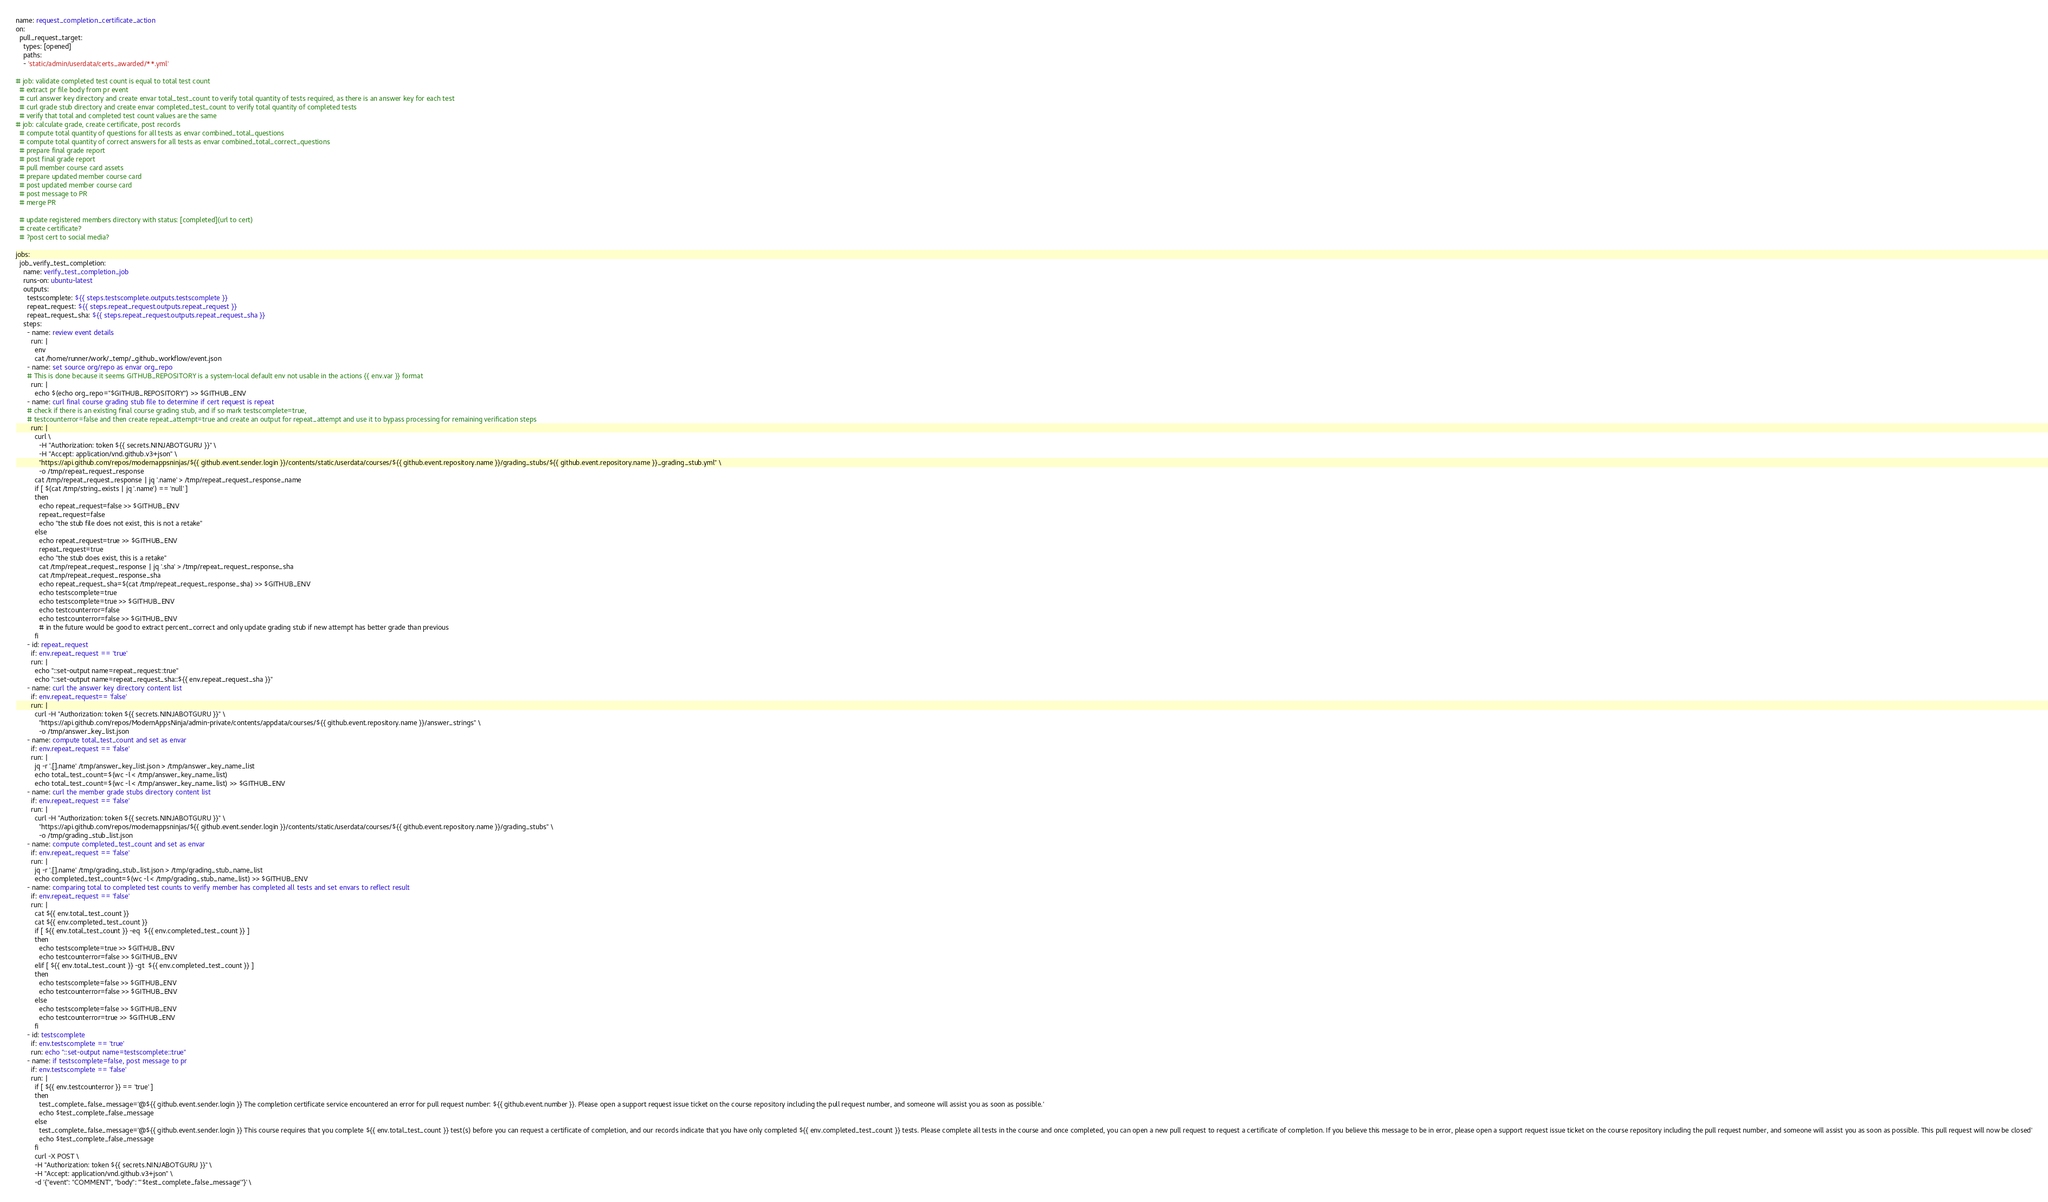<code> <loc_0><loc_0><loc_500><loc_500><_YAML_>name: request_completion_certificate_action
on:
  pull_request_target:
    types: [opened]
    paths:
    - 'static/admin/userdata/certs_awarded/**.yml'

# job: validate completed test count is equal to total test count
  # extract pr file body from pr event
  # curl answer key directory and create envar total_test_count to verify total quantity of tests required, as there is an answer key for each test
  # curl grade stub directory and create envar completed_test_count to verify total quantity of completed tests
  # verify that total and completed test count values are the same
# job: calculate grade, create certificate, post records
  # compute total quantity of questions for all tests as envar combined_total_questions
  # compute total quantity of correct answers for all tests as envar combined_total_correct_questions
  # prepare final grade report
  # post final grade report
  # pull member course card assets
  # prepare updated member course card
  # post updated member course card
  # post message to PR
  # merge PR
  
  # update registered members directory with status: [completed](url to cert)
  # create certificate?
  # ?post cert to social media?

jobs:
  job_verify_test_completion:
    name: verify_test_completion_job
    runs-on: ubuntu-latest
    outputs:
      testscomplete: ${{ steps.testscomplete.outputs.testscomplete }}
      repeat_request: ${{ steps.repeat_request.outputs.repeat_request }}
      repeat_request_sha: ${{ steps.repeat_request.outputs.repeat_request_sha }}
    steps:
      - name: review event details
        run: |
          env
          cat /home/runner/work/_temp/_github_workflow/event.json
      - name: set source org/repo as envar org_repo
      # This is done because it seems GITHUB_REPOSITORY is a system-local default env not usable in the actions {{ env.var }} format
        run: |
          echo $(echo org_repo="$GITHUB_REPOSITORY") >> $GITHUB_ENV
      - name: curl final course grading stub file to determine if cert request is repeat
      # check if there is an existing final course grading stub, and if so mark testscomplete=true, 
      # testcounterror=false and then create repeat_attempt=true and create an output for repeat_attempt and use it to bypass processing for remaining verification steps
        run: |
          curl \
            -H "Authorization: token ${{ secrets.NINJABOTGURU }}" \
            -H "Accept: application/vnd.github.v3+json" \
            "https://api.github.com/repos/modernappsninjas/${{ github.event.sender.login }}/contents/static/userdata/courses/${{ github.event.repository.name }}/grading_stubs/${{ github.event.repository.name }}_grading_stub.yml" \
            -o /tmp/repeat_request_response
          cat /tmp/repeat_request_response | jq '.name' > /tmp/repeat_request_response_name
          if [ $(cat /tmp/string_exists | jq '.name') == 'null' ]
          then
            echo repeat_request=false >> $GITHUB_ENV
            repeat_request=false
            echo "the stub file does not exist, this is not a retake"
          else
            echo repeat_request=true >> $GITHUB_ENV
            repeat_request=true
            echo "the stub does exist, this is a retake"
            cat /tmp/repeat_request_response | jq '.sha' > /tmp/repeat_request_response_sha
            cat /tmp/repeat_request_response_sha
            echo repeat_request_sha=$(cat /tmp/repeat_request_response_sha) >> $GITHUB_ENV
            echo testscomplete=true
            echo testscomplete=true >> $GITHUB_ENV
            echo testcounterror=false
            echo testcounterror=false >> $GITHUB_ENV 
            # in the future would be good to extract percent_correct and only update grading stub if new attempt has better grade than previous
          fi
      - id: repeat_request
        if: env.repeat_request == 'true'
        run: |
          echo "::set-output name=repeat_request::true"
          echo "::set-output name=repeat_request_sha::${{ env.repeat_request_sha }}"
      - name: curl the answer key directory content list
        if: env.repeat_request== 'false'
        run: |
          curl -H "Authorization: token ${{ secrets.NINJABOTGURU }}" \
            "https://api.github.com/repos/ModernAppsNinja/admin-private/contents/appdata/courses/${{ github.event.repository.name }}/answer_strings" \
            -o /tmp/answer_key_list.json
      - name: compute total_test_count and set as envar
        if: env.repeat_request == 'false'
        run: |  
          jq -r '.[].name' /tmp/answer_key_list.json > /tmp/answer_key_name_list
          echo total_test_count=$(wc -l < /tmp/answer_key_name_list)
          echo total_test_count=$(wc -l < /tmp/answer_key_name_list) >> $GITHUB_ENV
      - name: curl the member grade stubs directory content list
        if: env.repeat_request == 'false'
        run: |
          curl -H "Authorization: token ${{ secrets.NINJABOTGURU }}" \
            "https://api.github.com/repos/modernappsninjas/${{ github.event.sender.login }}/contents/static/userdata/courses/${{ github.event.repository.name }}/grading_stubs" \
            -o /tmp/grading_stub_list.json
      - name: compute completed_test_count and set as envar
        if: env.repeat_request == 'false'
        run: |  
          jq -r '.[].name' /tmp/grading_stub_list.json > /tmp/grading_stub_name_list
          echo completed_test_count=$(wc -l < /tmp/grading_stub_name_list) >> $GITHUB_ENV
      - name: comparing total to completed test counts to verify member has completed all tests and set envars to reflect result
        if: env.repeat_request == 'false'
        run: |
          cat ${{ env.total_test_count }}
          cat ${{ env.completed_test_count }}
          if [ ${{ env.total_test_count }} -eq  ${{ env.completed_test_count }} ]
          then 
            echo testscomplete=true >> $GITHUB_ENV
            echo testcounterror=false >> $GITHUB_ENV            
          elif [ ${{ env.total_test_count }} -gt  ${{ env.completed_test_count }} ]
          then 
            echo testscomplete=false >> $GITHUB_ENV
            echo testcounterror=false >> $GITHUB_ENV            
          else
            echo testscomplete=false >> $GITHUB_ENV
            echo testcounterror=true >> $GITHUB_ENV            
          fi
      - id: testscomplete
        if: env.testscomplete == 'true'
        run: echo "::set-output name=testscomplete::true"
      - name: if testscomplete=false, post message to pr
        if: env.testscomplete == 'false'
        run: |
          if [ ${{ env.testcounterror }} == 'true' ]
          then
            test_complete_false_message='@${{ github.event.sender.login }} The completion certificate service encountered an error for pull request number: ${{ github.event.number }}. Please open a support request issue ticket on the course repository including the pull request number, and someone will assist you as soon as possible.'
            echo $test_complete_false_message
          else
            test_complete_false_message='@${{ github.event.sender.login }} This course requires that you complete ${{ env.total_test_count }} test(s) before you can request a certificate of completion, and our records indicate that you have only completed ${{ env.completed_test_count }} tests. Please complete all tests in the course and once completed, you can open a new pull request to request a certificate of completion. If you believe this message to be in error, please open a support request issue ticket on the course repository including the pull request number, and someone will assist you as soon as possible. This pull request will now be closed'
            echo $test_complete_false_message
          fi
          curl -X POST \
          -H "Authorization: token ${{ secrets.NINJABOTGURU }}" \
          -H "Accept: application/vnd.github.v3+json" \
          -d '{"event": "COMMENT", "body": "'$test_complete_false_message'"}' \</code> 